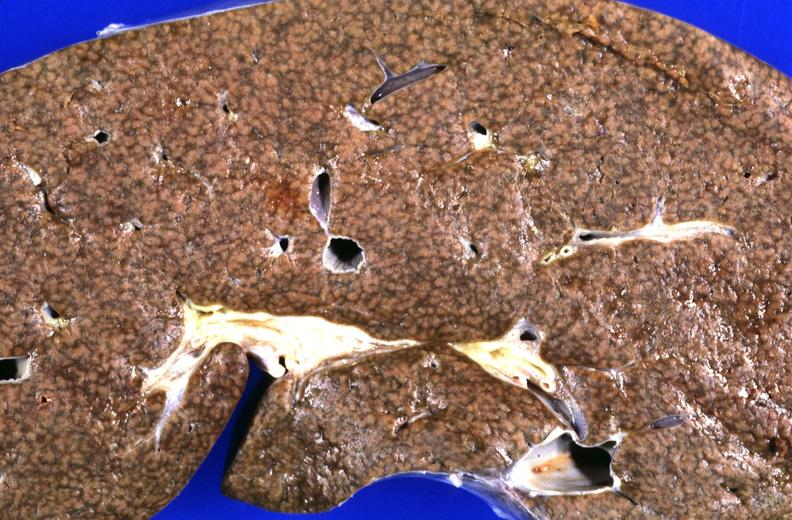s siamese twins present?
Answer the question using a single word or phrase. No 